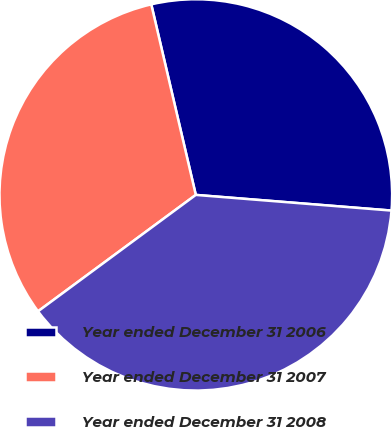Convert chart to OTSL. <chart><loc_0><loc_0><loc_500><loc_500><pie_chart><fcel>Year ended December 31 2006<fcel>Year ended December 31 2007<fcel>Year ended December 31 2008<nl><fcel>29.92%<fcel>31.5%<fcel>38.58%<nl></chart> 